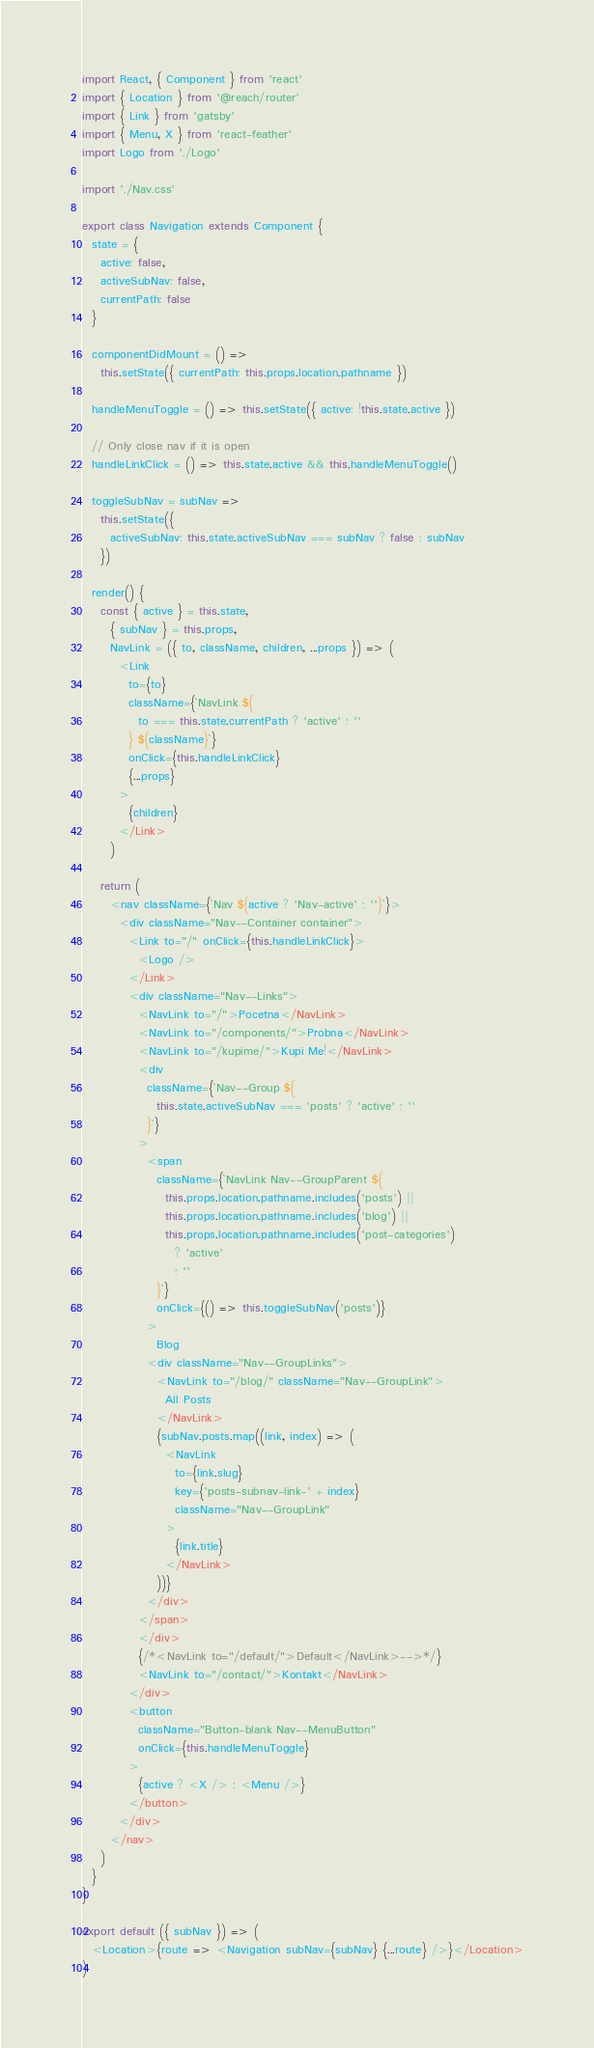Convert code to text. <code><loc_0><loc_0><loc_500><loc_500><_JavaScript_>import React, { Component } from 'react'
import { Location } from '@reach/router'
import { Link } from 'gatsby'
import { Menu, X } from 'react-feather'
import Logo from './Logo'

import './Nav.css'

export class Navigation extends Component {
  state = {
    active: false,
    activeSubNav: false,
    currentPath: false
  }

  componentDidMount = () =>
    this.setState({ currentPath: this.props.location.pathname })

  handleMenuToggle = () => this.setState({ active: !this.state.active })

  // Only close nav if it is open
  handleLinkClick = () => this.state.active && this.handleMenuToggle()

  toggleSubNav = subNav =>
    this.setState({
      activeSubNav: this.state.activeSubNav === subNav ? false : subNav
    })

  render() {
    const { active } = this.state,
      { subNav } = this.props,
      NavLink = ({ to, className, children, ...props }) => (
        <Link
          to={to}
          className={`NavLink ${
            to === this.state.currentPath ? 'active' : ''
          } ${className}`}
          onClick={this.handleLinkClick}
          {...props}
        >
          {children}
        </Link>
      )

    return (
      <nav className={`Nav ${active ? 'Nav-active' : ''}`}>
        <div className="Nav--Container container">
          <Link to="/" onClick={this.handleLinkClick}>
            <Logo />
          </Link>
          <div className="Nav--Links">
            <NavLink to="/">Pocetna</NavLink>
            <NavLink to="/components/">Probna</NavLink>
            <NavLink to="/kupime/">Kupi Me!</NavLink>
            <div
              className={`Nav--Group ${
                this.state.activeSubNav === 'posts' ? 'active' : ''
              }`}
            >
              <span
                className={`NavLink Nav--GroupParent ${
                  this.props.location.pathname.includes('posts') ||
                  this.props.location.pathname.includes('blog') ||
                  this.props.location.pathname.includes('post-categories')
                    ? 'active'
                    : ''
                }`}
                onClick={() => this.toggleSubNav('posts')}
              >
                Blog
              <div className="Nav--GroupLinks">
                <NavLink to="/blog/" className="Nav--GroupLink">
                  All Posts
                </NavLink>
                {subNav.posts.map((link, index) => (
                  <NavLink
                    to={link.slug}
                    key={'posts-subnav-link-' + index}
                    className="Nav--GroupLink"
                  >
                    {link.title}
                  </NavLink>
                ))}
              </div>
            </span>
            </div>
            {/*<NavLink to="/default/">Default</NavLink>-->*/}
            <NavLink to="/contact/">Kontakt</NavLink>
          </div>
          <button
            className="Button-blank Nav--MenuButton"
            onClick={this.handleMenuToggle}
          >
            {active ? <X /> : <Menu />}
          </button>
        </div>
      </nav>
    )
  }
}

export default ({ subNav }) => (
  <Location>{route => <Navigation subNav={subNav} {...route} />}</Location>
)
</code> 